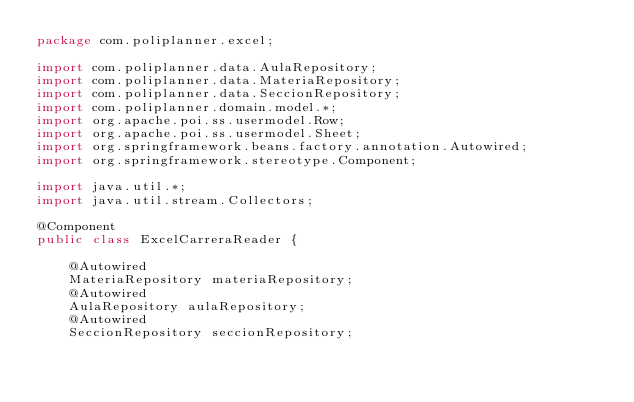<code> <loc_0><loc_0><loc_500><loc_500><_Java_>package com.poliplanner.excel;

import com.poliplanner.data.AulaRepository;
import com.poliplanner.data.MateriaRepository;
import com.poliplanner.data.SeccionRepository;
import com.poliplanner.domain.model.*;
import org.apache.poi.ss.usermodel.Row;
import org.apache.poi.ss.usermodel.Sheet;
import org.springframework.beans.factory.annotation.Autowired;
import org.springframework.stereotype.Component;

import java.util.*;
import java.util.stream.Collectors;

@Component
public class ExcelCarreraReader {

    @Autowired
    MateriaRepository materiaRepository;
    @Autowired
    AulaRepository aulaRepository;
    @Autowired
    SeccionRepository seccionRepository;
</code> 